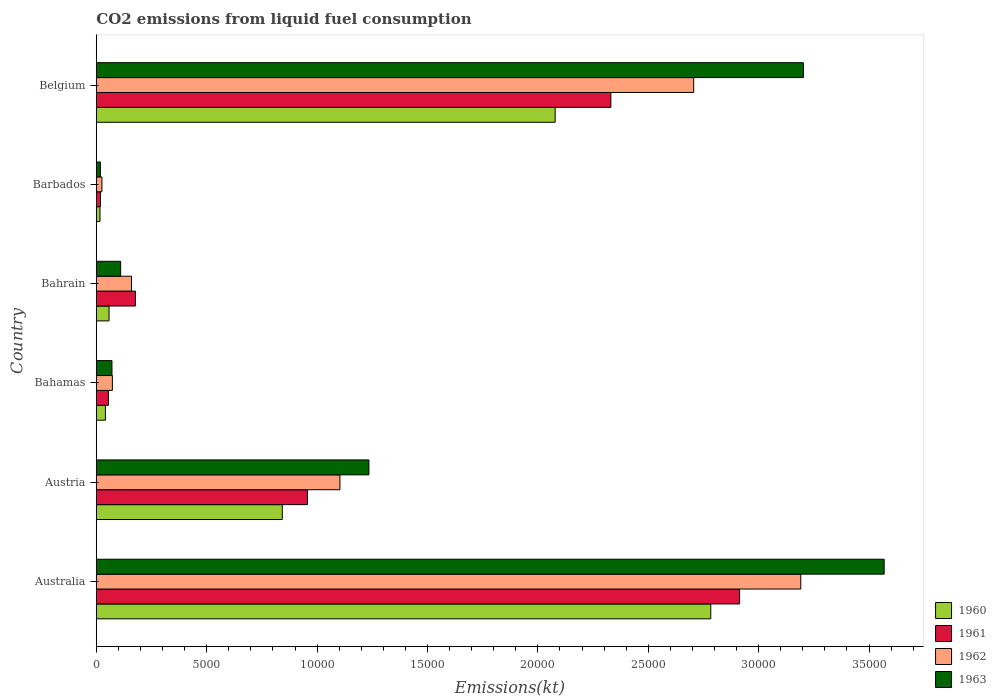How many different coloured bars are there?
Offer a terse response. 4. Are the number of bars per tick equal to the number of legend labels?
Ensure brevity in your answer.  Yes. Are the number of bars on each tick of the Y-axis equal?
Ensure brevity in your answer.  Yes. How many bars are there on the 4th tick from the top?
Provide a succinct answer. 4. How many bars are there on the 4th tick from the bottom?
Provide a succinct answer. 4. In how many cases, is the number of bars for a given country not equal to the number of legend labels?
Your answer should be compact. 0. What is the amount of CO2 emitted in 1961 in Austria?
Offer a terse response. 9559.87. Across all countries, what is the maximum amount of CO2 emitted in 1962?
Provide a succinct answer. 3.19e+04. Across all countries, what is the minimum amount of CO2 emitted in 1961?
Offer a very short reply. 187.02. In which country was the amount of CO2 emitted in 1960 minimum?
Offer a terse response. Barbados. What is the total amount of CO2 emitted in 1960 in the graph?
Ensure brevity in your answer.  5.82e+04. What is the difference between the amount of CO2 emitted in 1961 in Bahrain and that in Belgium?
Make the answer very short. -2.15e+04. What is the difference between the amount of CO2 emitted in 1963 in Bahrain and the amount of CO2 emitted in 1960 in Austria?
Offer a terse response. -7323. What is the average amount of CO2 emitted in 1962 per country?
Make the answer very short. 1.21e+04. What is the difference between the amount of CO2 emitted in 1960 and amount of CO2 emitted in 1962 in Bahamas?
Your response must be concise. -315.36. In how many countries, is the amount of CO2 emitted in 1963 greater than 1000 kt?
Keep it short and to the point. 4. What is the ratio of the amount of CO2 emitted in 1962 in Austria to that in Bahrain?
Make the answer very short. 6.93. Is the amount of CO2 emitted in 1961 in Austria less than that in Bahrain?
Your answer should be compact. No. Is the difference between the amount of CO2 emitted in 1960 in Barbados and Belgium greater than the difference between the amount of CO2 emitted in 1962 in Barbados and Belgium?
Keep it short and to the point. Yes. What is the difference between the highest and the second highest amount of CO2 emitted in 1960?
Your response must be concise. 7047.97. What is the difference between the highest and the lowest amount of CO2 emitted in 1963?
Offer a very short reply. 3.55e+04. In how many countries, is the amount of CO2 emitted in 1961 greater than the average amount of CO2 emitted in 1961 taken over all countries?
Give a very brief answer. 2. Is the sum of the amount of CO2 emitted in 1962 in Australia and Bahamas greater than the maximum amount of CO2 emitted in 1963 across all countries?
Ensure brevity in your answer.  No. What does the 3rd bar from the bottom in Belgium represents?
Your answer should be very brief. 1962. Are the values on the major ticks of X-axis written in scientific E-notation?
Make the answer very short. No. Does the graph contain grids?
Your answer should be compact. No. Where does the legend appear in the graph?
Ensure brevity in your answer.  Bottom right. How many legend labels are there?
Your answer should be very brief. 4. What is the title of the graph?
Your response must be concise. CO2 emissions from liquid fuel consumption. Does "1988" appear as one of the legend labels in the graph?
Provide a short and direct response. No. What is the label or title of the X-axis?
Make the answer very short. Emissions(kt). What is the label or title of the Y-axis?
Provide a succinct answer. Country. What is the Emissions(kt) in 1960 in Australia?
Provide a short and direct response. 2.78e+04. What is the Emissions(kt) in 1961 in Australia?
Offer a very short reply. 2.91e+04. What is the Emissions(kt) in 1962 in Australia?
Keep it short and to the point. 3.19e+04. What is the Emissions(kt) of 1963 in Australia?
Offer a terse response. 3.57e+04. What is the Emissions(kt) in 1960 in Austria?
Provide a short and direct response. 8423.1. What is the Emissions(kt) of 1961 in Austria?
Offer a very short reply. 9559.87. What is the Emissions(kt) in 1962 in Austria?
Keep it short and to the point. 1.10e+04. What is the Emissions(kt) of 1963 in Austria?
Ensure brevity in your answer.  1.23e+04. What is the Emissions(kt) of 1960 in Bahamas?
Your response must be concise. 410.7. What is the Emissions(kt) of 1961 in Bahamas?
Provide a succinct answer. 546.38. What is the Emissions(kt) in 1962 in Bahamas?
Your response must be concise. 726.07. What is the Emissions(kt) in 1963 in Bahamas?
Give a very brief answer. 707.73. What is the Emissions(kt) in 1960 in Bahrain?
Make the answer very short. 575.72. What is the Emissions(kt) of 1961 in Bahrain?
Keep it short and to the point. 1771.16. What is the Emissions(kt) of 1962 in Bahrain?
Offer a very short reply. 1591.48. What is the Emissions(kt) of 1963 in Bahrain?
Give a very brief answer. 1100.1. What is the Emissions(kt) of 1960 in Barbados?
Offer a terse response. 165.01. What is the Emissions(kt) in 1961 in Barbados?
Offer a very short reply. 187.02. What is the Emissions(kt) of 1962 in Barbados?
Make the answer very short. 253.02. What is the Emissions(kt) of 1963 in Barbados?
Provide a short and direct response. 183.35. What is the Emissions(kt) in 1960 in Belgium?
Offer a terse response. 2.08e+04. What is the Emissions(kt) in 1961 in Belgium?
Give a very brief answer. 2.33e+04. What is the Emissions(kt) in 1962 in Belgium?
Make the answer very short. 2.71e+04. What is the Emissions(kt) of 1963 in Belgium?
Your response must be concise. 3.20e+04. Across all countries, what is the maximum Emissions(kt) of 1960?
Make the answer very short. 2.78e+04. Across all countries, what is the maximum Emissions(kt) in 1961?
Give a very brief answer. 2.91e+04. Across all countries, what is the maximum Emissions(kt) in 1962?
Offer a very short reply. 3.19e+04. Across all countries, what is the maximum Emissions(kt) of 1963?
Give a very brief answer. 3.57e+04. Across all countries, what is the minimum Emissions(kt) in 1960?
Provide a succinct answer. 165.01. Across all countries, what is the minimum Emissions(kt) in 1961?
Provide a short and direct response. 187.02. Across all countries, what is the minimum Emissions(kt) in 1962?
Make the answer very short. 253.02. Across all countries, what is the minimum Emissions(kt) in 1963?
Your answer should be very brief. 183.35. What is the total Emissions(kt) in 1960 in the graph?
Keep it short and to the point. 5.82e+04. What is the total Emissions(kt) of 1961 in the graph?
Your answer should be compact. 6.45e+04. What is the total Emissions(kt) in 1962 in the graph?
Provide a short and direct response. 7.26e+04. What is the total Emissions(kt) in 1963 in the graph?
Give a very brief answer. 8.21e+04. What is the difference between the Emissions(kt) of 1960 in Australia and that in Austria?
Make the answer very short. 1.94e+04. What is the difference between the Emissions(kt) of 1961 in Australia and that in Austria?
Offer a very short reply. 1.96e+04. What is the difference between the Emissions(kt) of 1962 in Australia and that in Austria?
Your response must be concise. 2.09e+04. What is the difference between the Emissions(kt) in 1963 in Australia and that in Austria?
Give a very brief answer. 2.33e+04. What is the difference between the Emissions(kt) of 1960 in Australia and that in Bahamas?
Provide a succinct answer. 2.74e+04. What is the difference between the Emissions(kt) in 1961 in Australia and that in Bahamas?
Provide a succinct answer. 2.86e+04. What is the difference between the Emissions(kt) of 1962 in Australia and that in Bahamas?
Provide a short and direct response. 3.12e+04. What is the difference between the Emissions(kt) in 1963 in Australia and that in Bahamas?
Make the answer very short. 3.50e+04. What is the difference between the Emissions(kt) of 1960 in Australia and that in Bahrain?
Your response must be concise. 2.73e+04. What is the difference between the Emissions(kt) of 1961 in Australia and that in Bahrain?
Your response must be concise. 2.74e+04. What is the difference between the Emissions(kt) of 1962 in Australia and that in Bahrain?
Your answer should be compact. 3.03e+04. What is the difference between the Emissions(kt) of 1963 in Australia and that in Bahrain?
Your answer should be compact. 3.46e+04. What is the difference between the Emissions(kt) in 1960 in Australia and that in Barbados?
Your response must be concise. 2.77e+04. What is the difference between the Emissions(kt) in 1961 in Australia and that in Barbados?
Offer a terse response. 2.90e+04. What is the difference between the Emissions(kt) of 1962 in Australia and that in Barbados?
Provide a short and direct response. 3.17e+04. What is the difference between the Emissions(kt) in 1963 in Australia and that in Barbados?
Your answer should be very brief. 3.55e+04. What is the difference between the Emissions(kt) of 1960 in Australia and that in Belgium?
Offer a terse response. 7047.97. What is the difference between the Emissions(kt) of 1961 in Australia and that in Belgium?
Make the answer very short. 5830.53. What is the difference between the Emissions(kt) of 1962 in Australia and that in Belgium?
Your answer should be compact. 4851.44. What is the difference between the Emissions(kt) in 1963 in Australia and that in Belgium?
Your response must be concise. 3659.67. What is the difference between the Emissions(kt) of 1960 in Austria and that in Bahamas?
Your response must be concise. 8012.4. What is the difference between the Emissions(kt) of 1961 in Austria and that in Bahamas?
Make the answer very short. 9013.49. What is the difference between the Emissions(kt) of 1962 in Austria and that in Bahamas?
Ensure brevity in your answer.  1.03e+04. What is the difference between the Emissions(kt) in 1963 in Austria and that in Bahamas?
Ensure brevity in your answer.  1.16e+04. What is the difference between the Emissions(kt) of 1960 in Austria and that in Bahrain?
Make the answer very short. 7847.38. What is the difference between the Emissions(kt) of 1961 in Austria and that in Bahrain?
Your response must be concise. 7788.71. What is the difference between the Emissions(kt) in 1962 in Austria and that in Bahrain?
Your answer should be very brief. 9442.52. What is the difference between the Emissions(kt) in 1963 in Austria and that in Bahrain?
Give a very brief answer. 1.12e+04. What is the difference between the Emissions(kt) in 1960 in Austria and that in Barbados?
Make the answer very short. 8258.08. What is the difference between the Emissions(kt) of 1961 in Austria and that in Barbados?
Your response must be concise. 9372.85. What is the difference between the Emissions(kt) of 1962 in Austria and that in Barbados?
Give a very brief answer. 1.08e+04. What is the difference between the Emissions(kt) in 1963 in Austria and that in Barbados?
Provide a succinct answer. 1.22e+04. What is the difference between the Emissions(kt) of 1960 in Austria and that in Belgium?
Your answer should be very brief. -1.24e+04. What is the difference between the Emissions(kt) in 1961 in Austria and that in Belgium?
Keep it short and to the point. -1.37e+04. What is the difference between the Emissions(kt) in 1962 in Austria and that in Belgium?
Offer a terse response. -1.60e+04. What is the difference between the Emissions(kt) of 1963 in Austria and that in Belgium?
Make the answer very short. -1.97e+04. What is the difference between the Emissions(kt) in 1960 in Bahamas and that in Bahrain?
Your answer should be compact. -165.01. What is the difference between the Emissions(kt) of 1961 in Bahamas and that in Bahrain?
Offer a terse response. -1224.78. What is the difference between the Emissions(kt) in 1962 in Bahamas and that in Bahrain?
Give a very brief answer. -865.41. What is the difference between the Emissions(kt) of 1963 in Bahamas and that in Bahrain?
Provide a short and direct response. -392.37. What is the difference between the Emissions(kt) of 1960 in Bahamas and that in Barbados?
Your response must be concise. 245.69. What is the difference between the Emissions(kt) in 1961 in Bahamas and that in Barbados?
Offer a terse response. 359.37. What is the difference between the Emissions(kt) of 1962 in Bahamas and that in Barbados?
Make the answer very short. 473.04. What is the difference between the Emissions(kt) in 1963 in Bahamas and that in Barbados?
Make the answer very short. 524.38. What is the difference between the Emissions(kt) of 1960 in Bahamas and that in Belgium?
Provide a short and direct response. -2.04e+04. What is the difference between the Emissions(kt) of 1961 in Bahamas and that in Belgium?
Provide a short and direct response. -2.28e+04. What is the difference between the Emissions(kt) of 1962 in Bahamas and that in Belgium?
Your answer should be very brief. -2.63e+04. What is the difference between the Emissions(kt) in 1963 in Bahamas and that in Belgium?
Ensure brevity in your answer.  -3.13e+04. What is the difference between the Emissions(kt) of 1960 in Bahrain and that in Barbados?
Ensure brevity in your answer.  410.7. What is the difference between the Emissions(kt) of 1961 in Bahrain and that in Barbados?
Give a very brief answer. 1584.14. What is the difference between the Emissions(kt) of 1962 in Bahrain and that in Barbados?
Offer a terse response. 1338.45. What is the difference between the Emissions(kt) of 1963 in Bahrain and that in Barbados?
Your response must be concise. 916.75. What is the difference between the Emissions(kt) of 1960 in Bahrain and that in Belgium?
Your answer should be compact. -2.02e+04. What is the difference between the Emissions(kt) of 1961 in Bahrain and that in Belgium?
Make the answer very short. -2.15e+04. What is the difference between the Emissions(kt) in 1962 in Bahrain and that in Belgium?
Your answer should be very brief. -2.55e+04. What is the difference between the Emissions(kt) in 1963 in Bahrain and that in Belgium?
Offer a very short reply. -3.09e+04. What is the difference between the Emissions(kt) of 1960 in Barbados and that in Belgium?
Provide a succinct answer. -2.06e+04. What is the difference between the Emissions(kt) of 1961 in Barbados and that in Belgium?
Offer a very short reply. -2.31e+04. What is the difference between the Emissions(kt) in 1962 in Barbados and that in Belgium?
Offer a very short reply. -2.68e+04. What is the difference between the Emissions(kt) in 1963 in Barbados and that in Belgium?
Offer a very short reply. -3.18e+04. What is the difference between the Emissions(kt) of 1960 in Australia and the Emissions(kt) of 1961 in Austria?
Ensure brevity in your answer.  1.83e+04. What is the difference between the Emissions(kt) in 1960 in Australia and the Emissions(kt) in 1962 in Austria?
Provide a short and direct response. 1.68e+04. What is the difference between the Emissions(kt) in 1960 in Australia and the Emissions(kt) in 1963 in Austria?
Provide a short and direct response. 1.55e+04. What is the difference between the Emissions(kt) of 1961 in Australia and the Emissions(kt) of 1962 in Austria?
Your answer should be compact. 1.81e+04. What is the difference between the Emissions(kt) in 1961 in Australia and the Emissions(kt) in 1963 in Austria?
Your answer should be very brief. 1.68e+04. What is the difference between the Emissions(kt) in 1962 in Australia and the Emissions(kt) in 1963 in Austria?
Ensure brevity in your answer.  1.96e+04. What is the difference between the Emissions(kt) of 1960 in Australia and the Emissions(kt) of 1961 in Bahamas?
Ensure brevity in your answer.  2.73e+04. What is the difference between the Emissions(kt) in 1960 in Australia and the Emissions(kt) in 1962 in Bahamas?
Offer a very short reply. 2.71e+04. What is the difference between the Emissions(kt) of 1960 in Australia and the Emissions(kt) of 1963 in Bahamas?
Give a very brief answer. 2.71e+04. What is the difference between the Emissions(kt) in 1961 in Australia and the Emissions(kt) in 1962 in Bahamas?
Your answer should be compact. 2.84e+04. What is the difference between the Emissions(kt) of 1961 in Australia and the Emissions(kt) of 1963 in Bahamas?
Provide a succinct answer. 2.84e+04. What is the difference between the Emissions(kt) of 1962 in Australia and the Emissions(kt) of 1963 in Bahamas?
Provide a short and direct response. 3.12e+04. What is the difference between the Emissions(kt) of 1960 in Australia and the Emissions(kt) of 1961 in Bahrain?
Give a very brief answer. 2.61e+04. What is the difference between the Emissions(kt) of 1960 in Australia and the Emissions(kt) of 1962 in Bahrain?
Give a very brief answer. 2.62e+04. What is the difference between the Emissions(kt) in 1960 in Australia and the Emissions(kt) in 1963 in Bahrain?
Keep it short and to the point. 2.67e+04. What is the difference between the Emissions(kt) of 1961 in Australia and the Emissions(kt) of 1962 in Bahrain?
Make the answer very short. 2.75e+04. What is the difference between the Emissions(kt) in 1961 in Australia and the Emissions(kt) in 1963 in Bahrain?
Your answer should be very brief. 2.80e+04. What is the difference between the Emissions(kt) in 1962 in Australia and the Emissions(kt) in 1963 in Bahrain?
Your answer should be compact. 3.08e+04. What is the difference between the Emissions(kt) of 1960 in Australia and the Emissions(kt) of 1961 in Barbados?
Offer a terse response. 2.76e+04. What is the difference between the Emissions(kt) of 1960 in Australia and the Emissions(kt) of 1962 in Barbados?
Make the answer very short. 2.76e+04. What is the difference between the Emissions(kt) in 1960 in Australia and the Emissions(kt) in 1963 in Barbados?
Offer a very short reply. 2.76e+04. What is the difference between the Emissions(kt) in 1961 in Australia and the Emissions(kt) in 1962 in Barbados?
Make the answer very short. 2.89e+04. What is the difference between the Emissions(kt) of 1961 in Australia and the Emissions(kt) of 1963 in Barbados?
Provide a succinct answer. 2.90e+04. What is the difference between the Emissions(kt) in 1962 in Australia and the Emissions(kt) in 1963 in Barbados?
Ensure brevity in your answer.  3.17e+04. What is the difference between the Emissions(kt) of 1960 in Australia and the Emissions(kt) of 1961 in Belgium?
Make the answer very short. 4525.08. What is the difference between the Emissions(kt) in 1960 in Australia and the Emissions(kt) in 1962 in Belgium?
Keep it short and to the point. 773.74. What is the difference between the Emissions(kt) of 1960 in Australia and the Emissions(kt) of 1963 in Belgium?
Provide a succinct answer. -4195.05. What is the difference between the Emissions(kt) of 1961 in Australia and the Emissions(kt) of 1962 in Belgium?
Your answer should be very brief. 2079.19. What is the difference between the Emissions(kt) in 1961 in Australia and the Emissions(kt) in 1963 in Belgium?
Offer a terse response. -2889.6. What is the difference between the Emissions(kt) of 1962 in Australia and the Emissions(kt) of 1963 in Belgium?
Provide a short and direct response. -117.34. What is the difference between the Emissions(kt) of 1960 in Austria and the Emissions(kt) of 1961 in Bahamas?
Ensure brevity in your answer.  7876.72. What is the difference between the Emissions(kt) in 1960 in Austria and the Emissions(kt) in 1962 in Bahamas?
Provide a short and direct response. 7697.03. What is the difference between the Emissions(kt) of 1960 in Austria and the Emissions(kt) of 1963 in Bahamas?
Offer a terse response. 7715.37. What is the difference between the Emissions(kt) of 1961 in Austria and the Emissions(kt) of 1962 in Bahamas?
Ensure brevity in your answer.  8833.8. What is the difference between the Emissions(kt) of 1961 in Austria and the Emissions(kt) of 1963 in Bahamas?
Provide a succinct answer. 8852.14. What is the difference between the Emissions(kt) in 1962 in Austria and the Emissions(kt) in 1963 in Bahamas?
Offer a very short reply. 1.03e+04. What is the difference between the Emissions(kt) in 1960 in Austria and the Emissions(kt) in 1961 in Bahrain?
Provide a succinct answer. 6651.94. What is the difference between the Emissions(kt) of 1960 in Austria and the Emissions(kt) of 1962 in Bahrain?
Provide a short and direct response. 6831.62. What is the difference between the Emissions(kt) in 1960 in Austria and the Emissions(kt) in 1963 in Bahrain?
Give a very brief answer. 7323. What is the difference between the Emissions(kt) of 1961 in Austria and the Emissions(kt) of 1962 in Bahrain?
Your answer should be compact. 7968.39. What is the difference between the Emissions(kt) in 1961 in Austria and the Emissions(kt) in 1963 in Bahrain?
Ensure brevity in your answer.  8459.77. What is the difference between the Emissions(kt) of 1962 in Austria and the Emissions(kt) of 1963 in Bahrain?
Give a very brief answer. 9933.9. What is the difference between the Emissions(kt) in 1960 in Austria and the Emissions(kt) in 1961 in Barbados?
Your response must be concise. 8236.08. What is the difference between the Emissions(kt) in 1960 in Austria and the Emissions(kt) in 1962 in Barbados?
Your response must be concise. 8170.08. What is the difference between the Emissions(kt) of 1960 in Austria and the Emissions(kt) of 1963 in Barbados?
Offer a terse response. 8239.75. What is the difference between the Emissions(kt) in 1961 in Austria and the Emissions(kt) in 1962 in Barbados?
Offer a terse response. 9306.85. What is the difference between the Emissions(kt) in 1961 in Austria and the Emissions(kt) in 1963 in Barbados?
Your answer should be compact. 9376.52. What is the difference between the Emissions(kt) in 1962 in Austria and the Emissions(kt) in 1963 in Barbados?
Your answer should be very brief. 1.09e+04. What is the difference between the Emissions(kt) in 1960 in Austria and the Emissions(kt) in 1961 in Belgium?
Offer a very short reply. -1.49e+04. What is the difference between the Emissions(kt) in 1960 in Austria and the Emissions(kt) in 1962 in Belgium?
Provide a succinct answer. -1.86e+04. What is the difference between the Emissions(kt) in 1960 in Austria and the Emissions(kt) in 1963 in Belgium?
Offer a terse response. -2.36e+04. What is the difference between the Emissions(kt) of 1961 in Austria and the Emissions(kt) of 1962 in Belgium?
Provide a succinct answer. -1.75e+04. What is the difference between the Emissions(kt) in 1961 in Austria and the Emissions(kt) in 1963 in Belgium?
Provide a short and direct response. -2.25e+04. What is the difference between the Emissions(kt) of 1962 in Austria and the Emissions(kt) of 1963 in Belgium?
Offer a terse response. -2.10e+04. What is the difference between the Emissions(kt) in 1960 in Bahamas and the Emissions(kt) in 1961 in Bahrain?
Make the answer very short. -1360.46. What is the difference between the Emissions(kt) in 1960 in Bahamas and the Emissions(kt) in 1962 in Bahrain?
Your response must be concise. -1180.77. What is the difference between the Emissions(kt) in 1960 in Bahamas and the Emissions(kt) in 1963 in Bahrain?
Keep it short and to the point. -689.4. What is the difference between the Emissions(kt) of 1961 in Bahamas and the Emissions(kt) of 1962 in Bahrain?
Give a very brief answer. -1045.1. What is the difference between the Emissions(kt) of 1961 in Bahamas and the Emissions(kt) of 1963 in Bahrain?
Offer a terse response. -553.72. What is the difference between the Emissions(kt) of 1962 in Bahamas and the Emissions(kt) of 1963 in Bahrain?
Provide a succinct answer. -374.03. What is the difference between the Emissions(kt) of 1960 in Bahamas and the Emissions(kt) of 1961 in Barbados?
Your response must be concise. 223.69. What is the difference between the Emissions(kt) in 1960 in Bahamas and the Emissions(kt) in 1962 in Barbados?
Provide a short and direct response. 157.68. What is the difference between the Emissions(kt) in 1960 in Bahamas and the Emissions(kt) in 1963 in Barbados?
Your answer should be very brief. 227.35. What is the difference between the Emissions(kt) of 1961 in Bahamas and the Emissions(kt) of 1962 in Barbados?
Make the answer very short. 293.36. What is the difference between the Emissions(kt) of 1961 in Bahamas and the Emissions(kt) of 1963 in Barbados?
Your answer should be very brief. 363.03. What is the difference between the Emissions(kt) in 1962 in Bahamas and the Emissions(kt) in 1963 in Barbados?
Provide a short and direct response. 542.72. What is the difference between the Emissions(kt) in 1960 in Bahamas and the Emissions(kt) in 1961 in Belgium?
Give a very brief answer. -2.29e+04. What is the difference between the Emissions(kt) in 1960 in Bahamas and the Emissions(kt) in 1962 in Belgium?
Your answer should be very brief. -2.66e+04. What is the difference between the Emissions(kt) in 1960 in Bahamas and the Emissions(kt) in 1963 in Belgium?
Your response must be concise. -3.16e+04. What is the difference between the Emissions(kt) in 1961 in Bahamas and the Emissions(kt) in 1962 in Belgium?
Offer a terse response. -2.65e+04. What is the difference between the Emissions(kt) of 1961 in Bahamas and the Emissions(kt) of 1963 in Belgium?
Provide a short and direct response. -3.15e+04. What is the difference between the Emissions(kt) in 1962 in Bahamas and the Emissions(kt) in 1963 in Belgium?
Provide a short and direct response. -3.13e+04. What is the difference between the Emissions(kt) of 1960 in Bahrain and the Emissions(kt) of 1961 in Barbados?
Offer a terse response. 388.7. What is the difference between the Emissions(kt) in 1960 in Bahrain and the Emissions(kt) in 1962 in Barbados?
Ensure brevity in your answer.  322.7. What is the difference between the Emissions(kt) in 1960 in Bahrain and the Emissions(kt) in 1963 in Barbados?
Your answer should be compact. 392.37. What is the difference between the Emissions(kt) of 1961 in Bahrain and the Emissions(kt) of 1962 in Barbados?
Offer a terse response. 1518.14. What is the difference between the Emissions(kt) of 1961 in Bahrain and the Emissions(kt) of 1963 in Barbados?
Keep it short and to the point. 1587.81. What is the difference between the Emissions(kt) of 1962 in Bahrain and the Emissions(kt) of 1963 in Barbados?
Your answer should be compact. 1408.13. What is the difference between the Emissions(kt) in 1960 in Bahrain and the Emissions(kt) in 1961 in Belgium?
Keep it short and to the point. -2.27e+04. What is the difference between the Emissions(kt) in 1960 in Bahrain and the Emissions(kt) in 1962 in Belgium?
Ensure brevity in your answer.  -2.65e+04. What is the difference between the Emissions(kt) in 1960 in Bahrain and the Emissions(kt) in 1963 in Belgium?
Provide a succinct answer. -3.15e+04. What is the difference between the Emissions(kt) of 1961 in Bahrain and the Emissions(kt) of 1962 in Belgium?
Offer a very short reply. -2.53e+04. What is the difference between the Emissions(kt) in 1961 in Bahrain and the Emissions(kt) in 1963 in Belgium?
Your answer should be compact. -3.03e+04. What is the difference between the Emissions(kt) of 1962 in Bahrain and the Emissions(kt) of 1963 in Belgium?
Offer a very short reply. -3.04e+04. What is the difference between the Emissions(kt) of 1960 in Barbados and the Emissions(kt) of 1961 in Belgium?
Offer a terse response. -2.31e+04. What is the difference between the Emissions(kt) in 1960 in Barbados and the Emissions(kt) in 1962 in Belgium?
Provide a short and direct response. -2.69e+04. What is the difference between the Emissions(kt) in 1960 in Barbados and the Emissions(kt) in 1963 in Belgium?
Your answer should be compact. -3.19e+04. What is the difference between the Emissions(kt) of 1961 in Barbados and the Emissions(kt) of 1962 in Belgium?
Provide a succinct answer. -2.69e+04. What is the difference between the Emissions(kt) in 1961 in Barbados and the Emissions(kt) in 1963 in Belgium?
Your answer should be compact. -3.18e+04. What is the difference between the Emissions(kt) of 1962 in Barbados and the Emissions(kt) of 1963 in Belgium?
Keep it short and to the point. -3.18e+04. What is the average Emissions(kt) of 1960 per country?
Ensure brevity in your answer.  9698.6. What is the average Emissions(kt) in 1961 per country?
Your response must be concise. 1.08e+04. What is the average Emissions(kt) of 1962 per country?
Offer a very short reply. 1.21e+04. What is the average Emissions(kt) in 1963 per country?
Keep it short and to the point. 1.37e+04. What is the difference between the Emissions(kt) in 1960 and Emissions(kt) in 1961 in Australia?
Your answer should be very brief. -1305.45. What is the difference between the Emissions(kt) of 1960 and Emissions(kt) of 1962 in Australia?
Your answer should be compact. -4077.7. What is the difference between the Emissions(kt) of 1960 and Emissions(kt) of 1963 in Australia?
Your answer should be compact. -7854.71. What is the difference between the Emissions(kt) of 1961 and Emissions(kt) of 1962 in Australia?
Your answer should be very brief. -2772.25. What is the difference between the Emissions(kt) in 1961 and Emissions(kt) in 1963 in Australia?
Your answer should be very brief. -6549.26. What is the difference between the Emissions(kt) of 1962 and Emissions(kt) of 1963 in Australia?
Offer a very short reply. -3777.01. What is the difference between the Emissions(kt) in 1960 and Emissions(kt) in 1961 in Austria?
Ensure brevity in your answer.  -1136.77. What is the difference between the Emissions(kt) in 1960 and Emissions(kt) in 1962 in Austria?
Your answer should be very brief. -2610.9. What is the difference between the Emissions(kt) in 1960 and Emissions(kt) in 1963 in Austria?
Your answer should be very brief. -3923.69. What is the difference between the Emissions(kt) in 1961 and Emissions(kt) in 1962 in Austria?
Your answer should be very brief. -1474.13. What is the difference between the Emissions(kt) of 1961 and Emissions(kt) of 1963 in Austria?
Offer a very short reply. -2786.92. What is the difference between the Emissions(kt) of 1962 and Emissions(kt) of 1963 in Austria?
Your answer should be compact. -1312.79. What is the difference between the Emissions(kt) of 1960 and Emissions(kt) of 1961 in Bahamas?
Your response must be concise. -135.68. What is the difference between the Emissions(kt) in 1960 and Emissions(kt) in 1962 in Bahamas?
Your answer should be very brief. -315.36. What is the difference between the Emissions(kt) in 1960 and Emissions(kt) in 1963 in Bahamas?
Provide a succinct answer. -297.03. What is the difference between the Emissions(kt) in 1961 and Emissions(kt) in 1962 in Bahamas?
Your answer should be compact. -179.68. What is the difference between the Emissions(kt) of 1961 and Emissions(kt) of 1963 in Bahamas?
Ensure brevity in your answer.  -161.35. What is the difference between the Emissions(kt) in 1962 and Emissions(kt) in 1963 in Bahamas?
Give a very brief answer. 18.34. What is the difference between the Emissions(kt) in 1960 and Emissions(kt) in 1961 in Bahrain?
Provide a succinct answer. -1195.44. What is the difference between the Emissions(kt) in 1960 and Emissions(kt) in 1962 in Bahrain?
Make the answer very short. -1015.76. What is the difference between the Emissions(kt) of 1960 and Emissions(kt) of 1963 in Bahrain?
Ensure brevity in your answer.  -524.38. What is the difference between the Emissions(kt) in 1961 and Emissions(kt) in 1962 in Bahrain?
Ensure brevity in your answer.  179.68. What is the difference between the Emissions(kt) of 1961 and Emissions(kt) of 1963 in Bahrain?
Make the answer very short. 671.06. What is the difference between the Emissions(kt) of 1962 and Emissions(kt) of 1963 in Bahrain?
Your answer should be compact. 491.38. What is the difference between the Emissions(kt) of 1960 and Emissions(kt) of 1961 in Barbados?
Provide a succinct answer. -22. What is the difference between the Emissions(kt) in 1960 and Emissions(kt) in 1962 in Barbados?
Ensure brevity in your answer.  -88.01. What is the difference between the Emissions(kt) of 1960 and Emissions(kt) of 1963 in Barbados?
Keep it short and to the point. -18.34. What is the difference between the Emissions(kt) in 1961 and Emissions(kt) in 1962 in Barbados?
Your response must be concise. -66.01. What is the difference between the Emissions(kt) of 1961 and Emissions(kt) of 1963 in Barbados?
Offer a very short reply. 3.67. What is the difference between the Emissions(kt) in 1962 and Emissions(kt) in 1963 in Barbados?
Make the answer very short. 69.67. What is the difference between the Emissions(kt) of 1960 and Emissions(kt) of 1961 in Belgium?
Your response must be concise. -2522.9. What is the difference between the Emissions(kt) of 1960 and Emissions(kt) of 1962 in Belgium?
Keep it short and to the point. -6274.24. What is the difference between the Emissions(kt) in 1960 and Emissions(kt) in 1963 in Belgium?
Your answer should be very brief. -1.12e+04. What is the difference between the Emissions(kt) in 1961 and Emissions(kt) in 1962 in Belgium?
Your answer should be very brief. -3751.34. What is the difference between the Emissions(kt) in 1961 and Emissions(kt) in 1963 in Belgium?
Ensure brevity in your answer.  -8720.13. What is the difference between the Emissions(kt) in 1962 and Emissions(kt) in 1963 in Belgium?
Make the answer very short. -4968.78. What is the ratio of the Emissions(kt) in 1960 in Australia to that in Austria?
Keep it short and to the point. 3.3. What is the ratio of the Emissions(kt) of 1961 in Australia to that in Austria?
Provide a short and direct response. 3.05. What is the ratio of the Emissions(kt) of 1962 in Australia to that in Austria?
Ensure brevity in your answer.  2.89. What is the ratio of the Emissions(kt) of 1963 in Australia to that in Austria?
Your answer should be very brief. 2.89. What is the ratio of the Emissions(kt) of 1960 in Australia to that in Bahamas?
Offer a terse response. 67.77. What is the ratio of the Emissions(kt) of 1961 in Australia to that in Bahamas?
Keep it short and to the point. 53.33. What is the ratio of the Emissions(kt) in 1962 in Australia to that in Bahamas?
Make the answer very short. 43.95. What is the ratio of the Emissions(kt) of 1963 in Australia to that in Bahamas?
Keep it short and to the point. 50.42. What is the ratio of the Emissions(kt) of 1960 in Australia to that in Bahrain?
Give a very brief answer. 48.34. What is the ratio of the Emissions(kt) in 1961 in Australia to that in Bahrain?
Offer a very short reply. 16.45. What is the ratio of the Emissions(kt) of 1962 in Australia to that in Bahrain?
Ensure brevity in your answer.  20.05. What is the ratio of the Emissions(kt) in 1963 in Australia to that in Bahrain?
Your answer should be very brief. 32.44. What is the ratio of the Emissions(kt) of 1960 in Australia to that in Barbados?
Provide a succinct answer. 168.67. What is the ratio of the Emissions(kt) of 1961 in Australia to that in Barbados?
Your answer should be compact. 155.8. What is the ratio of the Emissions(kt) in 1962 in Australia to that in Barbados?
Provide a succinct answer. 126.12. What is the ratio of the Emissions(kt) in 1963 in Australia to that in Barbados?
Provide a succinct answer. 194.64. What is the ratio of the Emissions(kt) in 1960 in Australia to that in Belgium?
Offer a terse response. 1.34. What is the ratio of the Emissions(kt) in 1961 in Australia to that in Belgium?
Your answer should be compact. 1.25. What is the ratio of the Emissions(kt) in 1962 in Australia to that in Belgium?
Provide a short and direct response. 1.18. What is the ratio of the Emissions(kt) of 1963 in Australia to that in Belgium?
Your response must be concise. 1.11. What is the ratio of the Emissions(kt) in 1960 in Austria to that in Bahamas?
Provide a succinct answer. 20.51. What is the ratio of the Emissions(kt) of 1961 in Austria to that in Bahamas?
Make the answer very short. 17.5. What is the ratio of the Emissions(kt) in 1962 in Austria to that in Bahamas?
Your answer should be compact. 15.2. What is the ratio of the Emissions(kt) of 1963 in Austria to that in Bahamas?
Keep it short and to the point. 17.45. What is the ratio of the Emissions(kt) in 1960 in Austria to that in Bahrain?
Give a very brief answer. 14.63. What is the ratio of the Emissions(kt) in 1961 in Austria to that in Bahrain?
Your answer should be very brief. 5.4. What is the ratio of the Emissions(kt) in 1962 in Austria to that in Bahrain?
Give a very brief answer. 6.93. What is the ratio of the Emissions(kt) of 1963 in Austria to that in Bahrain?
Your answer should be compact. 11.22. What is the ratio of the Emissions(kt) of 1960 in Austria to that in Barbados?
Keep it short and to the point. 51.04. What is the ratio of the Emissions(kt) of 1961 in Austria to that in Barbados?
Provide a short and direct response. 51.12. What is the ratio of the Emissions(kt) in 1962 in Austria to that in Barbados?
Provide a short and direct response. 43.61. What is the ratio of the Emissions(kt) of 1963 in Austria to that in Barbados?
Provide a short and direct response. 67.34. What is the ratio of the Emissions(kt) of 1960 in Austria to that in Belgium?
Provide a succinct answer. 0.41. What is the ratio of the Emissions(kt) of 1961 in Austria to that in Belgium?
Provide a succinct answer. 0.41. What is the ratio of the Emissions(kt) of 1962 in Austria to that in Belgium?
Offer a very short reply. 0.41. What is the ratio of the Emissions(kt) of 1963 in Austria to that in Belgium?
Offer a very short reply. 0.39. What is the ratio of the Emissions(kt) in 1960 in Bahamas to that in Bahrain?
Your response must be concise. 0.71. What is the ratio of the Emissions(kt) of 1961 in Bahamas to that in Bahrain?
Keep it short and to the point. 0.31. What is the ratio of the Emissions(kt) of 1962 in Bahamas to that in Bahrain?
Your answer should be compact. 0.46. What is the ratio of the Emissions(kt) of 1963 in Bahamas to that in Bahrain?
Offer a terse response. 0.64. What is the ratio of the Emissions(kt) of 1960 in Bahamas to that in Barbados?
Your response must be concise. 2.49. What is the ratio of the Emissions(kt) of 1961 in Bahamas to that in Barbados?
Your response must be concise. 2.92. What is the ratio of the Emissions(kt) in 1962 in Bahamas to that in Barbados?
Your answer should be very brief. 2.87. What is the ratio of the Emissions(kt) of 1963 in Bahamas to that in Barbados?
Your response must be concise. 3.86. What is the ratio of the Emissions(kt) in 1960 in Bahamas to that in Belgium?
Your response must be concise. 0.02. What is the ratio of the Emissions(kt) in 1961 in Bahamas to that in Belgium?
Keep it short and to the point. 0.02. What is the ratio of the Emissions(kt) in 1962 in Bahamas to that in Belgium?
Provide a succinct answer. 0.03. What is the ratio of the Emissions(kt) of 1963 in Bahamas to that in Belgium?
Keep it short and to the point. 0.02. What is the ratio of the Emissions(kt) of 1960 in Bahrain to that in Barbados?
Provide a short and direct response. 3.49. What is the ratio of the Emissions(kt) in 1961 in Bahrain to that in Barbados?
Your answer should be very brief. 9.47. What is the ratio of the Emissions(kt) in 1962 in Bahrain to that in Barbados?
Give a very brief answer. 6.29. What is the ratio of the Emissions(kt) in 1963 in Bahrain to that in Barbados?
Ensure brevity in your answer.  6. What is the ratio of the Emissions(kt) in 1960 in Bahrain to that in Belgium?
Offer a terse response. 0.03. What is the ratio of the Emissions(kt) in 1961 in Bahrain to that in Belgium?
Keep it short and to the point. 0.08. What is the ratio of the Emissions(kt) in 1962 in Bahrain to that in Belgium?
Your response must be concise. 0.06. What is the ratio of the Emissions(kt) of 1963 in Bahrain to that in Belgium?
Keep it short and to the point. 0.03. What is the ratio of the Emissions(kt) of 1960 in Barbados to that in Belgium?
Offer a very short reply. 0.01. What is the ratio of the Emissions(kt) in 1961 in Barbados to that in Belgium?
Provide a short and direct response. 0.01. What is the ratio of the Emissions(kt) in 1962 in Barbados to that in Belgium?
Make the answer very short. 0.01. What is the ratio of the Emissions(kt) of 1963 in Barbados to that in Belgium?
Your answer should be very brief. 0.01. What is the difference between the highest and the second highest Emissions(kt) of 1960?
Ensure brevity in your answer.  7047.97. What is the difference between the highest and the second highest Emissions(kt) in 1961?
Your response must be concise. 5830.53. What is the difference between the highest and the second highest Emissions(kt) of 1962?
Provide a succinct answer. 4851.44. What is the difference between the highest and the second highest Emissions(kt) of 1963?
Give a very brief answer. 3659.67. What is the difference between the highest and the lowest Emissions(kt) of 1960?
Offer a terse response. 2.77e+04. What is the difference between the highest and the lowest Emissions(kt) in 1961?
Offer a terse response. 2.90e+04. What is the difference between the highest and the lowest Emissions(kt) of 1962?
Provide a succinct answer. 3.17e+04. What is the difference between the highest and the lowest Emissions(kt) in 1963?
Give a very brief answer. 3.55e+04. 